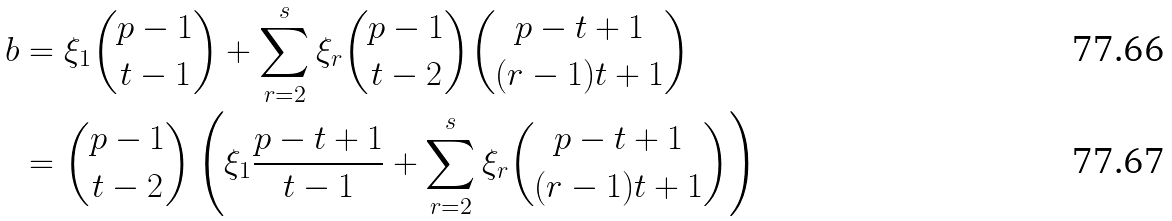Convert formula to latex. <formula><loc_0><loc_0><loc_500><loc_500>b & = \xi _ { 1 } \binom { p - 1 } { t - 1 } + \sum _ { r = 2 } ^ { s } \xi _ { r } \binom { p - 1 } { t - 2 } \binom { p - t + 1 } { ( r - 1 ) t + 1 } \\ & = \binom { p - 1 } { t - 2 } \left ( \xi _ { 1 } \frac { p - t + 1 } { t - 1 } + \sum _ { r = 2 } ^ { s } \xi _ { r } \binom { p - t + 1 } { ( r - 1 ) t + 1 } \right )</formula> 